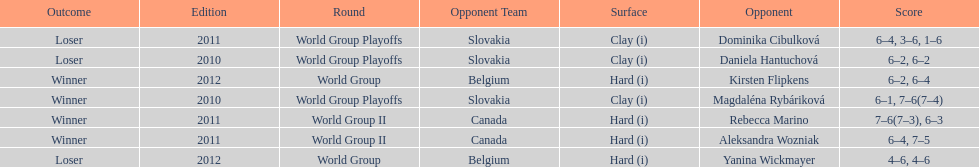Did they beat canada in more or less than 3 matches? Less. Would you mind parsing the complete table? {'header': ['Outcome', 'Edition', 'Round', 'Opponent Team', 'Surface', 'Opponent', 'Score'], 'rows': [['Loser', '2011', 'World Group Playoffs', 'Slovakia', 'Clay (i)', 'Dominika Cibulková', '6–4, 3–6, 1–6'], ['Loser', '2010', 'World Group Playoffs', 'Slovakia', 'Clay (i)', 'Daniela Hantuchová', '6–2, 6–2'], ['Winner', '2012', 'World Group', 'Belgium', 'Hard (i)', 'Kirsten Flipkens', '6–2, 6–4'], ['Winner', '2010', 'World Group Playoffs', 'Slovakia', 'Clay (i)', 'Magdaléna Rybáriková', '6–1, 7–6(7–4)'], ['Winner', '2011', 'World Group II', 'Canada', 'Hard (i)', 'Rebecca Marino', '7–6(7–3), 6–3'], ['Winner', '2011', 'World Group II', 'Canada', 'Hard (i)', 'Aleksandra Wozniak', '6–4, 7–5'], ['Loser', '2012', 'World Group', 'Belgium', 'Hard (i)', 'Yanina Wickmayer', '4–6, 4–6']]} 